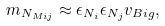<formula> <loc_0><loc_0><loc_500><loc_500>m _ { N _ { M i j } } \approx \epsilon _ { N _ { i } } \epsilon _ { N _ { j } } v _ { B i g } ,</formula> 